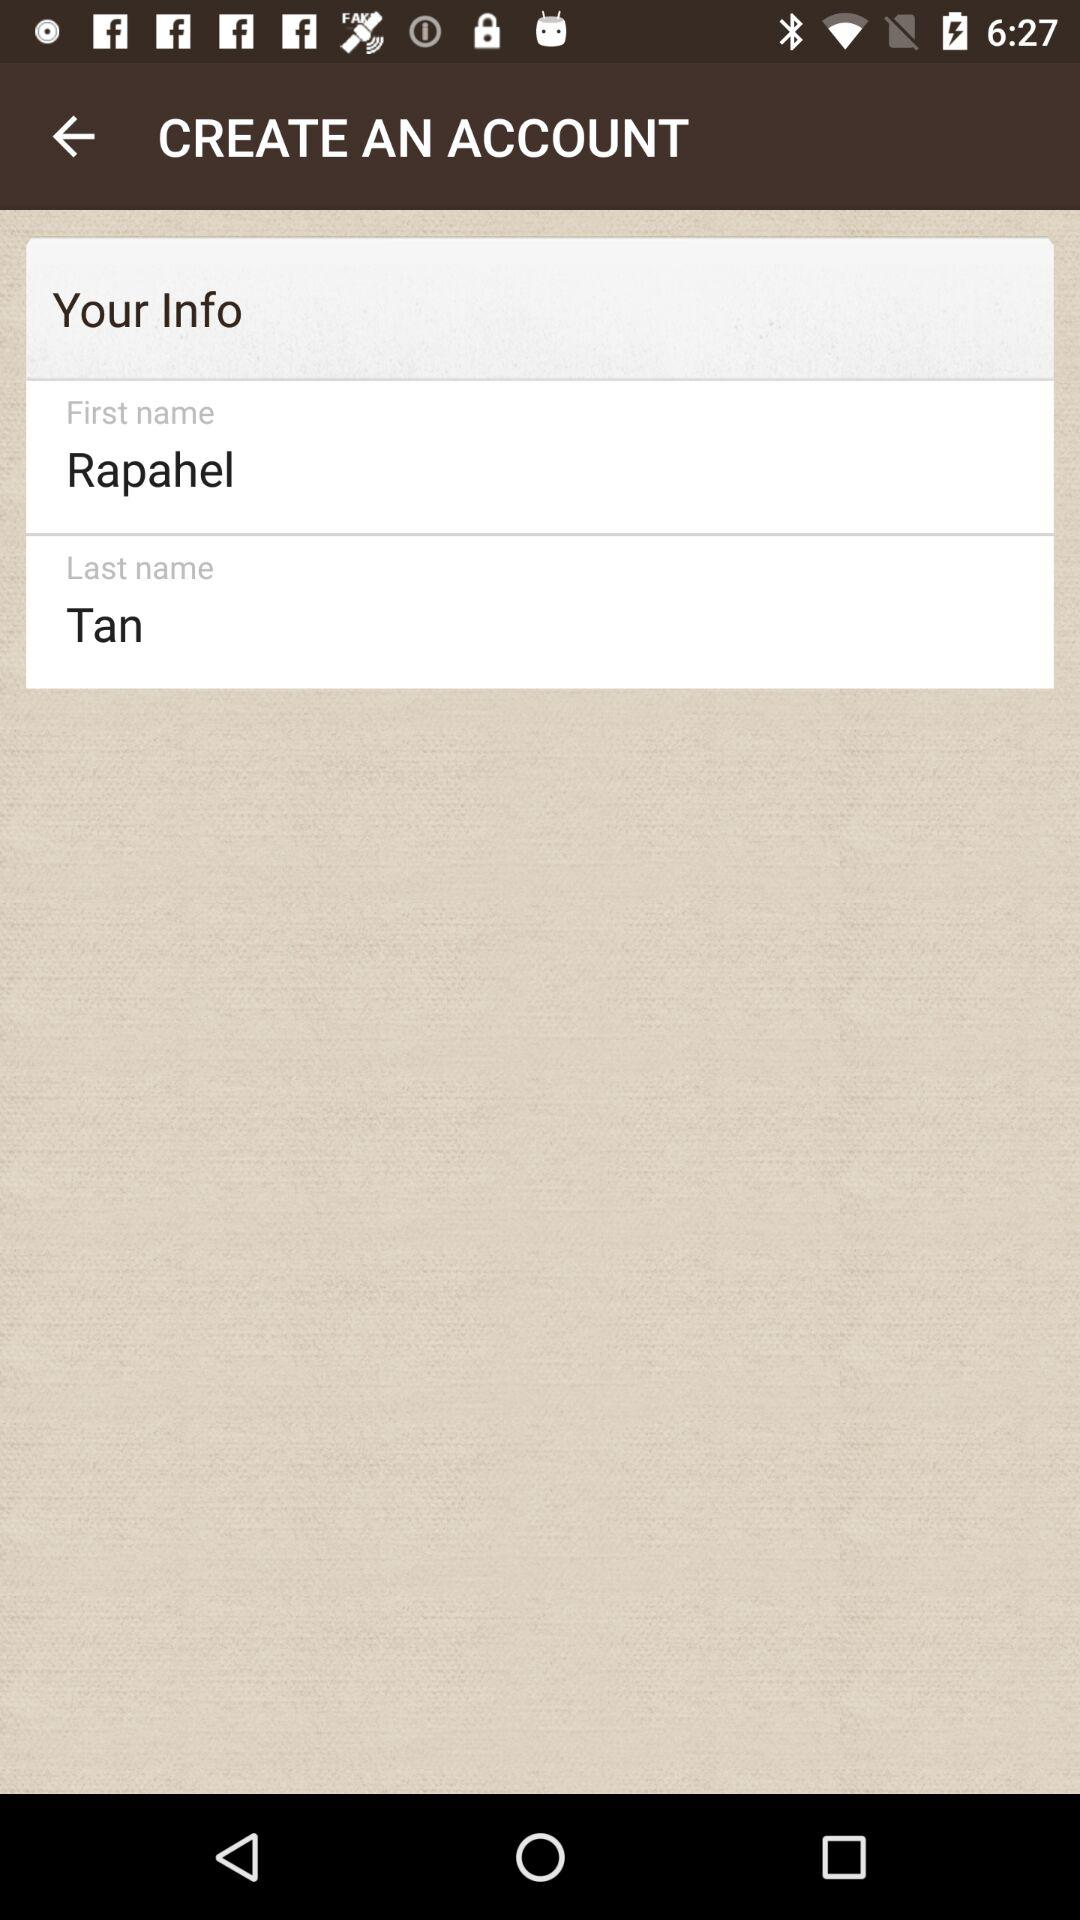What is the first name? The first name is Rapahel. 